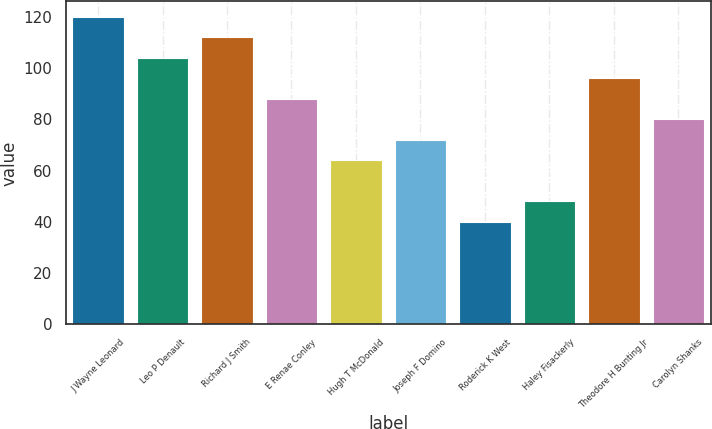Convert chart. <chart><loc_0><loc_0><loc_500><loc_500><bar_chart><fcel>J Wayne Leonard<fcel>Leo P Denault<fcel>Richard J Smith<fcel>E Renae Conley<fcel>Hugh T McDonald<fcel>Joseph F Domino<fcel>Roderick K West<fcel>Haley Fisackerly<fcel>Theodore H Bunting Jr<fcel>Carolyn Shanks<nl><fcel>120<fcel>104<fcel>112<fcel>88<fcel>64<fcel>72<fcel>40<fcel>48<fcel>96<fcel>80<nl></chart> 